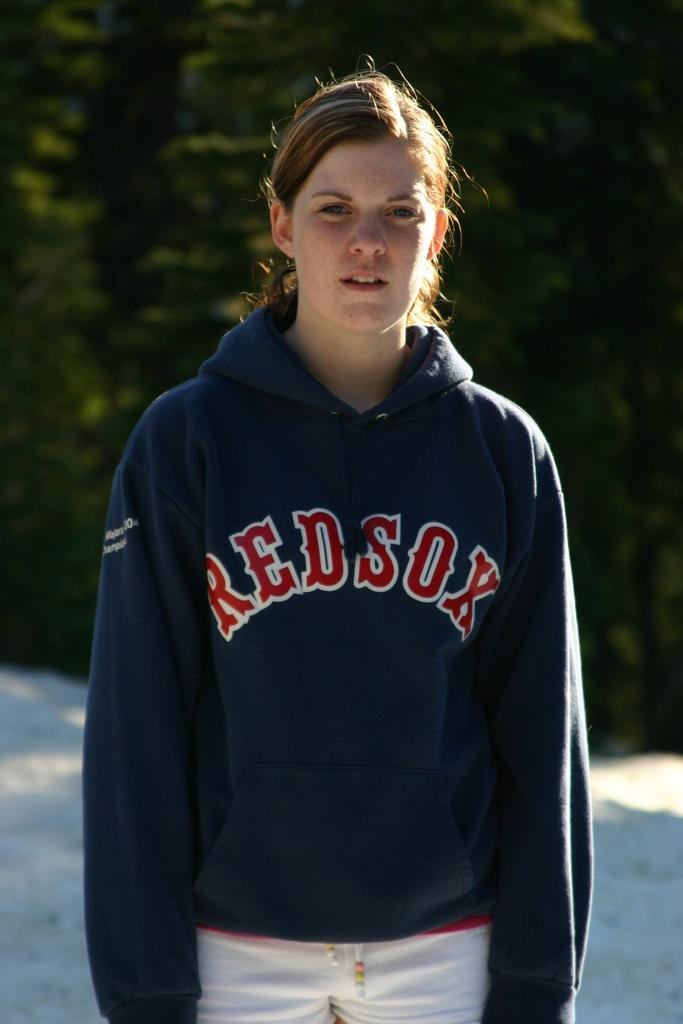<image>
Provide a brief description of the given image. A girl is standing and looking at the camera with a REDSOX hoodie on her. 